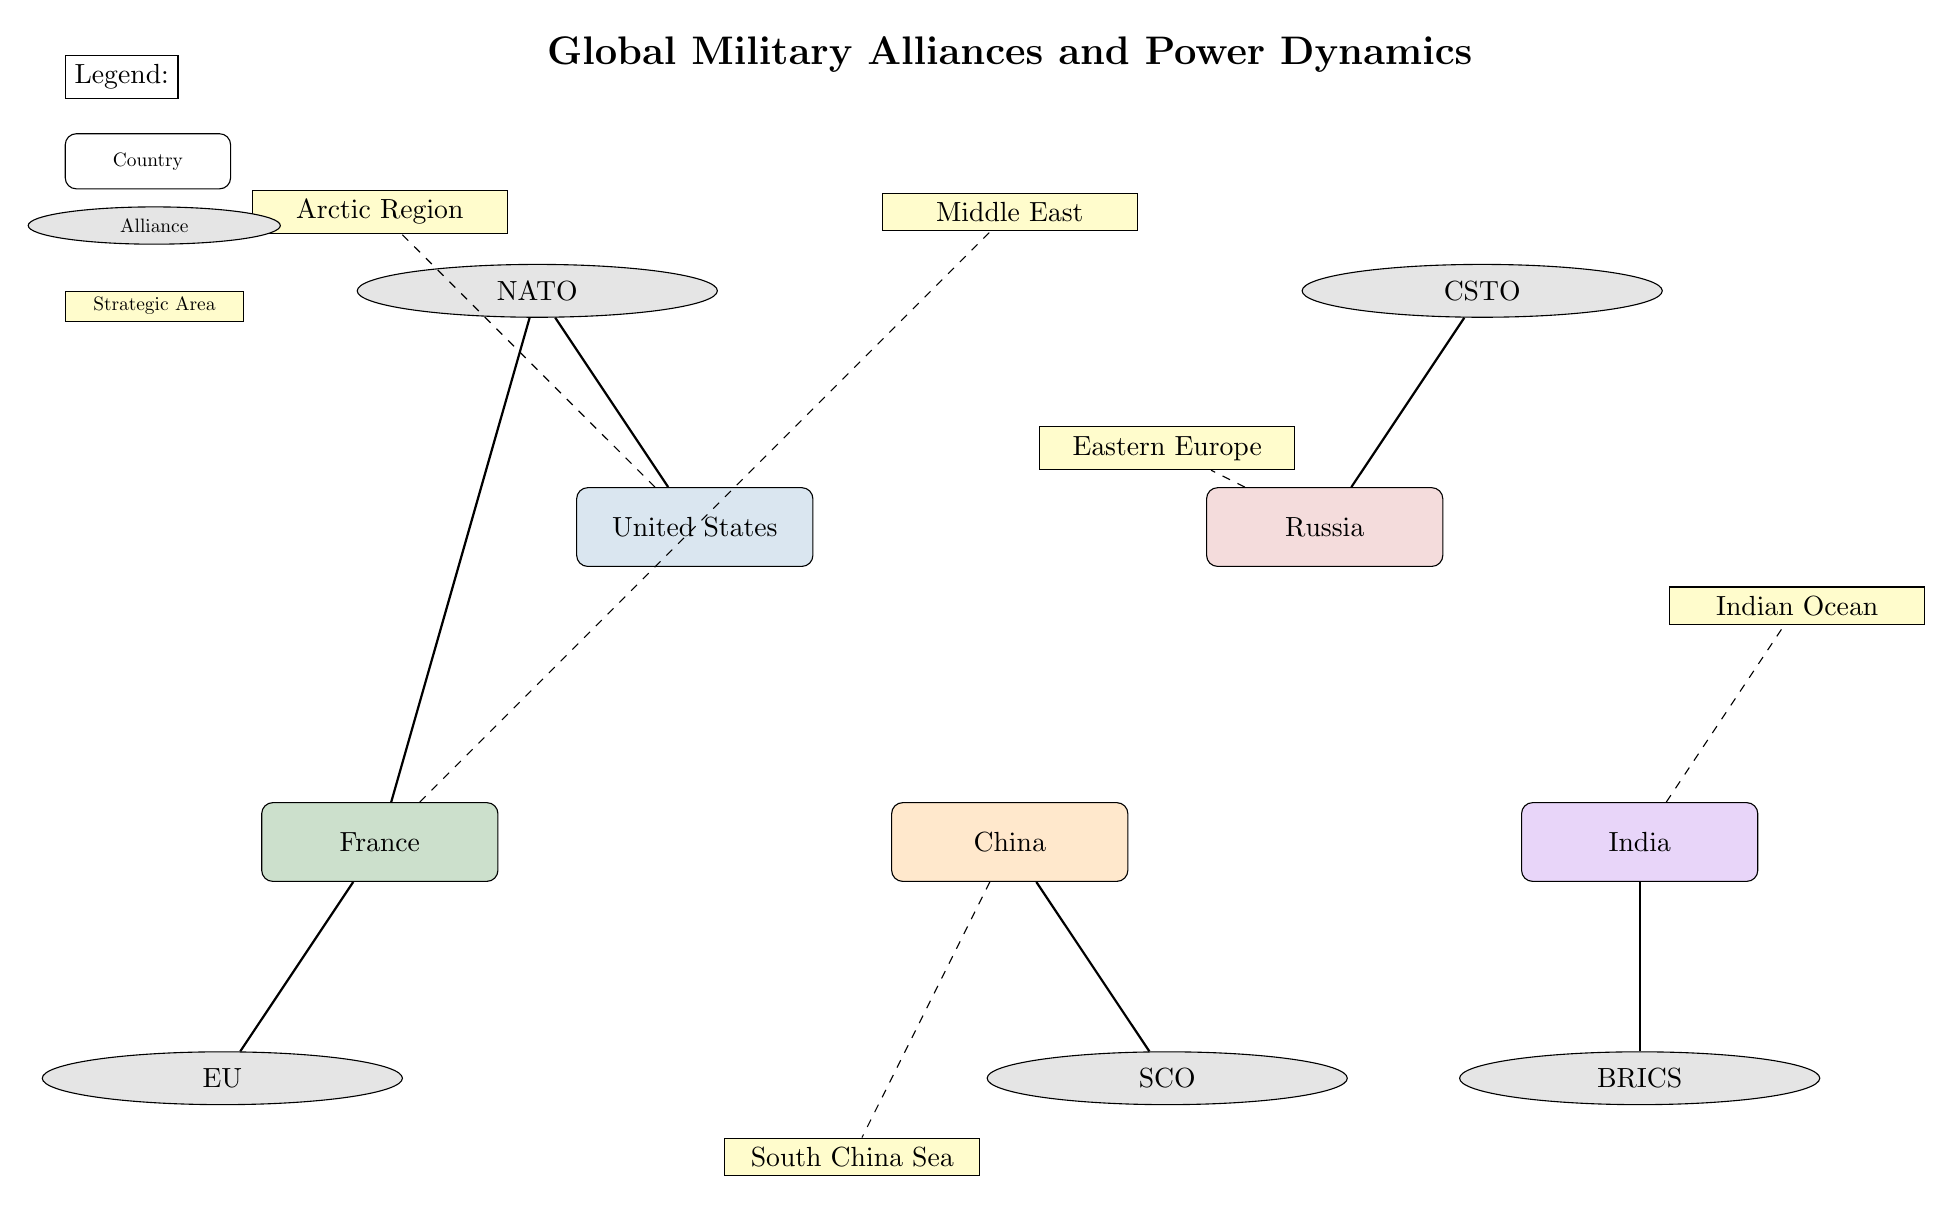What countries are members of NATO? The diagram shows that the United States and France are both connected to the NATO alliance. Therefore, the members of NATO in this context are these two countries.
Answer: United States, France Which alliance is associated with China? The diagram illustrates a connection from China to the SCO alliance. Hence, the alliance associated with China is SCO.
Answer: SCO How many strategic areas are annotated in the diagram? The diagram clearly lists five distinct strategic areas: South China Sea, Middle East, Eastern Europe, Indian Ocean, and Arctic Region. Therefore, the count of strategic areas is five.
Answer: 5 Which country in the diagram is linked to the Indian Ocean? The diagram indicates that India is connected to the Indian Ocean, as implied by the dashed line leading to that region.
Answer: India Which countries are members of BRICS? According to the diagram, the only country explicitly mentioned as a member of BRICS is India, which has a direct link to this alliance.
Answer: India What does CSTO stand for? The acronym CSTO refers to the Collective Security Treaty Organization as indicated by its position in the diagram linked with Russia.
Answer: Collective Security Treaty Organization Which two countries are part of the Eastern Europe influence zone? The diagram shows a link from Russia to Eastern Europe, and by elimination, the other country in this zone could be inferred as being France due to its proximity and strategic interests in the area. Thus, the countries are Russia and France.
Answer: Russia, France How are the alliances organized on the map? The diagram organizes alliances by geographic location, with NATO and CSTO positioned at the top and BRICS, SCO, and EU at the bottom, indicating power blocs from the West to the East.
Answer: By geographic location Which country has a direct connection to the South China Sea? In the diagram, the dashed line from China leads directly to the South China Sea, indicating that China has a connection to this strategic area.
Answer: China 